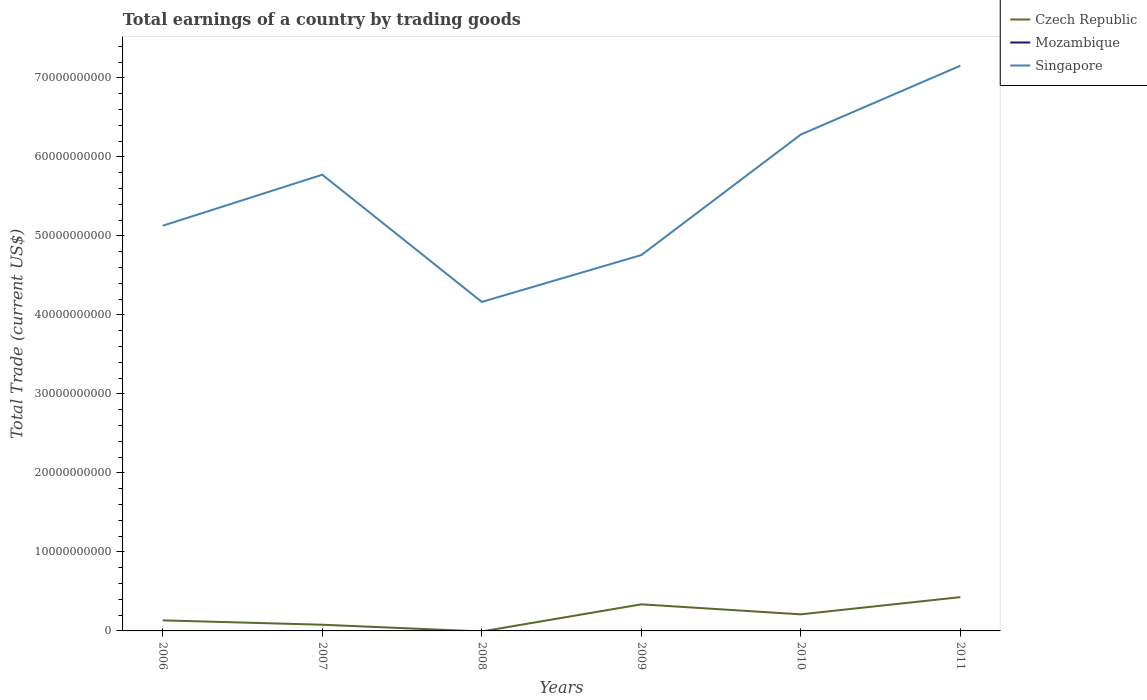How many different coloured lines are there?
Provide a succinct answer. 2. Does the line corresponding to Singapore intersect with the line corresponding to Czech Republic?
Make the answer very short. No. What is the total total earnings in Singapore in the graph?
Keep it short and to the point. 3.71e+09. What is the difference between the highest and the second highest total earnings in Singapore?
Provide a succinct answer. 2.99e+1. What is the difference between the highest and the lowest total earnings in Mozambique?
Make the answer very short. 0. Is the total earnings in Czech Republic strictly greater than the total earnings in Singapore over the years?
Provide a short and direct response. Yes. How many lines are there?
Provide a short and direct response. 2. Does the graph contain grids?
Provide a succinct answer. No. What is the title of the graph?
Your answer should be compact. Total earnings of a country by trading goods. Does "Small states" appear as one of the legend labels in the graph?
Your answer should be very brief. No. What is the label or title of the Y-axis?
Provide a short and direct response. Total Trade (current US$). What is the Total Trade (current US$) of Czech Republic in 2006?
Offer a terse response. 1.34e+09. What is the Total Trade (current US$) in Mozambique in 2006?
Your response must be concise. 0. What is the Total Trade (current US$) of Singapore in 2006?
Offer a terse response. 5.13e+1. What is the Total Trade (current US$) in Czech Republic in 2007?
Your answer should be compact. 7.83e+08. What is the Total Trade (current US$) of Singapore in 2007?
Your answer should be very brief. 5.77e+1. What is the Total Trade (current US$) of Singapore in 2008?
Your answer should be compact. 4.16e+1. What is the Total Trade (current US$) of Czech Republic in 2009?
Ensure brevity in your answer.  3.37e+09. What is the Total Trade (current US$) of Mozambique in 2009?
Your response must be concise. 0. What is the Total Trade (current US$) in Singapore in 2009?
Make the answer very short. 4.76e+1. What is the Total Trade (current US$) of Czech Republic in 2010?
Your answer should be compact. 2.10e+09. What is the Total Trade (current US$) of Singapore in 2010?
Provide a succinct answer. 6.28e+1. What is the Total Trade (current US$) in Czech Republic in 2011?
Your response must be concise. 4.28e+09. What is the Total Trade (current US$) of Mozambique in 2011?
Offer a very short reply. 0. What is the Total Trade (current US$) in Singapore in 2011?
Offer a very short reply. 7.15e+1. Across all years, what is the maximum Total Trade (current US$) of Czech Republic?
Give a very brief answer. 4.28e+09. Across all years, what is the maximum Total Trade (current US$) of Singapore?
Keep it short and to the point. 7.15e+1. Across all years, what is the minimum Total Trade (current US$) of Singapore?
Offer a very short reply. 4.16e+1. What is the total Total Trade (current US$) of Czech Republic in the graph?
Your answer should be very brief. 1.19e+1. What is the total Total Trade (current US$) in Singapore in the graph?
Make the answer very short. 3.33e+11. What is the difference between the Total Trade (current US$) in Czech Republic in 2006 and that in 2007?
Give a very brief answer. 5.55e+08. What is the difference between the Total Trade (current US$) of Singapore in 2006 and that in 2007?
Offer a terse response. -6.46e+09. What is the difference between the Total Trade (current US$) in Singapore in 2006 and that in 2008?
Keep it short and to the point. 9.65e+09. What is the difference between the Total Trade (current US$) of Czech Republic in 2006 and that in 2009?
Make the answer very short. -2.03e+09. What is the difference between the Total Trade (current US$) of Singapore in 2006 and that in 2009?
Offer a terse response. 3.71e+09. What is the difference between the Total Trade (current US$) in Czech Republic in 2006 and that in 2010?
Ensure brevity in your answer.  -7.61e+08. What is the difference between the Total Trade (current US$) in Singapore in 2006 and that in 2010?
Give a very brief answer. -1.15e+1. What is the difference between the Total Trade (current US$) of Czech Republic in 2006 and that in 2011?
Provide a succinct answer. -2.94e+09. What is the difference between the Total Trade (current US$) of Singapore in 2006 and that in 2011?
Your response must be concise. -2.03e+1. What is the difference between the Total Trade (current US$) of Singapore in 2007 and that in 2008?
Make the answer very short. 1.61e+1. What is the difference between the Total Trade (current US$) in Czech Republic in 2007 and that in 2009?
Give a very brief answer. -2.58e+09. What is the difference between the Total Trade (current US$) of Singapore in 2007 and that in 2009?
Offer a terse response. 1.02e+1. What is the difference between the Total Trade (current US$) in Czech Republic in 2007 and that in 2010?
Offer a very short reply. -1.32e+09. What is the difference between the Total Trade (current US$) in Singapore in 2007 and that in 2010?
Give a very brief answer. -5.09e+09. What is the difference between the Total Trade (current US$) in Czech Republic in 2007 and that in 2011?
Your response must be concise. -3.49e+09. What is the difference between the Total Trade (current US$) of Singapore in 2007 and that in 2011?
Offer a terse response. -1.38e+1. What is the difference between the Total Trade (current US$) in Singapore in 2008 and that in 2009?
Give a very brief answer. -5.93e+09. What is the difference between the Total Trade (current US$) of Singapore in 2008 and that in 2010?
Your answer should be very brief. -2.12e+1. What is the difference between the Total Trade (current US$) in Singapore in 2008 and that in 2011?
Keep it short and to the point. -2.99e+1. What is the difference between the Total Trade (current US$) in Czech Republic in 2009 and that in 2010?
Make the answer very short. 1.27e+09. What is the difference between the Total Trade (current US$) in Singapore in 2009 and that in 2010?
Keep it short and to the point. -1.53e+1. What is the difference between the Total Trade (current US$) of Czech Republic in 2009 and that in 2011?
Give a very brief answer. -9.11e+08. What is the difference between the Total Trade (current US$) in Singapore in 2009 and that in 2011?
Offer a very short reply. -2.40e+1. What is the difference between the Total Trade (current US$) of Czech Republic in 2010 and that in 2011?
Your answer should be very brief. -2.18e+09. What is the difference between the Total Trade (current US$) in Singapore in 2010 and that in 2011?
Keep it short and to the point. -8.71e+09. What is the difference between the Total Trade (current US$) of Czech Republic in 2006 and the Total Trade (current US$) of Singapore in 2007?
Ensure brevity in your answer.  -5.64e+1. What is the difference between the Total Trade (current US$) of Czech Republic in 2006 and the Total Trade (current US$) of Singapore in 2008?
Provide a short and direct response. -4.03e+1. What is the difference between the Total Trade (current US$) of Czech Republic in 2006 and the Total Trade (current US$) of Singapore in 2009?
Your answer should be compact. -4.62e+1. What is the difference between the Total Trade (current US$) of Czech Republic in 2006 and the Total Trade (current US$) of Singapore in 2010?
Ensure brevity in your answer.  -6.15e+1. What is the difference between the Total Trade (current US$) in Czech Republic in 2006 and the Total Trade (current US$) in Singapore in 2011?
Your answer should be very brief. -7.02e+1. What is the difference between the Total Trade (current US$) in Czech Republic in 2007 and the Total Trade (current US$) in Singapore in 2008?
Keep it short and to the point. -4.09e+1. What is the difference between the Total Trade (current US$) in Czech Republic in 2007 and the Total Trade (current US$) in Singapore in 2009?
Provide a succinct answer. -4.68e+1. What is the difference between the Total Trade (current US$) in Czech Republic in 2007 and the Total Trade (current US$) in Singapore in 2010?
Ensure brevity in your answer.  -6.21e+1. What is the difference between the Total Trade (current US$) in Czech Republic in 2007 and the Total Trade (current US$) in Singapore in 2011?
Your response must be concise. -7.08e+1. What is the difference between the Total Trade (current US$) in Czech Republic in 2009 and the Total Trade (current US$) in Singapore in 2010?
Your answer should be very brief. -5.95e+1. What is the difference between the Total Trade (current US$) of Czech Republic in 2009 and the Total Trade (current US$) of Singapore in 2011?
Provide a short and direct response. -6.82e+1. What is the difference between the Total Trade (current US$) in Czech Republic in 2010 and the Total Trade (current US$) in Singapore in 2011?
Offer a very short reply. -6.94e+1. What is the average Total Trade (current US$) of Czech Republic per year?
Your answer should be very brief. 1.98e+09. What is the average Total Trade (current US$) in Mozambique per year?
Provide a short and direct response. 0. What is the average Total Trade (current US$) in Singapore per year?
Provide a short and direct response. 5.54e+1. In the year 2006, what is the difference between the Total Trade (current US$) of Czech Republic and Total Trade (current US$) of Singapore?
Your response must be concise. -5.00e+1. In the year 2007, what is the difference between the Total Trade (current US$) of Czech Republic and Total Trade (current US$) of Singapore?
Your answer should be compact. -5.70e+1. In the year 2009, what is the difference between the Total Trade (current US$) of Czech Republic and Total Trade (current US$) of Singapore?
Provide a short and direct response. -4.42e+1. In the year 2010, what is the difference between the Total Trade (current US$) of Czech Republic and Total Trade (current US$) of Singapore?
Make the answer very short. -6.07e+1. In the year 2011, what is the difference between the Total Trade (current US$) of Czech Republic and Total Trade (current US$) of Singapore?
Offer a terse response. -6.73e+1. What is the ratio of the Total Trade (current US$) in Czech Republic in 2006 to that in 2007?
Give a very brief answer. 1.71. What is the ratio of the Total Trade (current US$) of Singapore in 2006 to that in 2007?
Offer a terse response. 0.89. What is the ratio of the Total Trade (current US$) in Singapore in 2006 to that in 2008?
Make the answer very short. 1.23. What is the ratio of the Total Trade (current US$) in Czech Republic in 2006 to that in 2009?
Your answer should be very brief. 0.4. What is the ratio of the Total Trade (current US$) in Singapore in 2006 to that in 2009?
Provide a succinct answer. 1.08. What is the ratio of the Total Trade (current US$) of Czech Republic in 2006 to that in 2010?
Your answer should be compact. 0.64. What is the ratio of the Total Trade (current US$) of Singapore in 2006 to that in 2010?
Your response must be concise. 0.82. What is the ratio of the Total Trade (current US$) of Czech Republic in 2006 to that in 2011?
Provide a succinct answer. 0.31. What is the ratio of the Total Trade (current US$) in Singapore in 2006 to that in 2011?
Make the answer very short. 0.72. What is the ratio of the Total Trade (current US$) in Singapore in 2007 to that in 2008?
Give a very brief answer. 1.39. What is the ratio of the Total Trade (current US$) of Czech Republic in 2007 to that in 2009?
Provide a short and direct response. 0.23. What is the ratio of the Total Trade (current US$) of Singapore in 2007 to that in 2009?
Keep it short and to the point. 1.21. What is the ratio of the Total Trade (current US$) in Czech Republic in 2007 to that in 2010?
Your answer should be very brief. 0.37. What is the ratio of the Total Trade (current US$) in Singapore in 2007 to that in 2010?
Make the answer very short. 0.92. What is the ratio of the Total Trade (current US$) in Czech Republic in 2007 to that in 2011?
Ensure brevity in your answer.  0.18. What is the ratio of the Total Trade (current US$) in Singapore in 2007 to that in 2011?
Make the answer very short. 0.81. What is the ratio of the Total Trade (current US$) in Singapore in 2008 to that in 2009?
Offer a very short reply. 0.88. What is the ratio of the Total Trade (current US$) of Singapore in 2008 to that in 2010?
Give a very brief answer. 0.66. What is the ratio of the Total Trade (current US$) of Singapore in 2008 to that in 2011?
Provide a succinct answer. 0.58. What is the ratio of the Total Trade (current US$) of Czech Republic in 2009 to that in 2010?
Provide a succinct answer. 1.6. What is the ratio of the Total Trade (current US$) of Singapore in 2009 to that in 2010?
Make the answer very short. 0.76. What is the ratio of the Total Trade (current US$) in Czech Republic in 2009 to that in 2011?
Keep it short and to the point. 0.79. What is the ratio of the Total Trade (current US$) of Singapore in 2009 to that in 2011?
Offer a very short reply. 0.67. What is the ratio of the Total Trade (current US$) in Czech Republic in 2010 to that in 2011?
Keep it short and to the point. 0.49. What is the ratio of the Total Trade (current US$) in Singapore in 2010 to that in 2011?
Your answer should be compact. 0.88. What is the difference between the highest and the second highest Total Trade (current US$) of Czech Republic?
Your answer should be very brief. 9.11e+08. What is the difference between the highest and the second highest Total Trade (current US$) of Singapore?
Offer a very short reply. 8.71e+09. What is the difference between the highest and the lowest Total Trade (current US$) in Czech Republic?
Ensure brevity in your answer.  4.28e+09. What is the difference between the highest and the lowest Total Trade (current US$) of Singapore?
Offer a very short reply. 2.99e+1. 